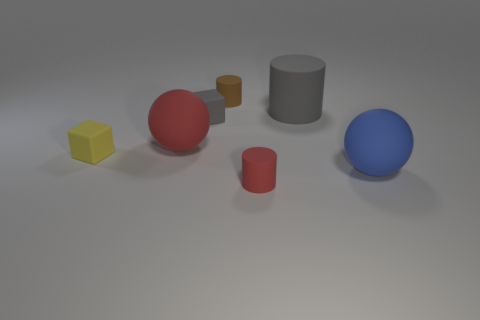Are there any gray things of the same shape as the big blue rubber object?
Make the answer very short. No. Is the number of big yellow shiny spheres less than the number of gray matte cylinders?
Your response must be concise. Yes. Do the small brown thing and the tiny red matte thing have the same shape?
Your answer should be compact. Yes. What number of objects are large blue rubber spheres or red rubber things in front of the yellow rubber cube?
Keep it short and to the point. 2. How many large gray cylinders are there?
Offer a very short reply. 1. Are there any red things of the same size as the yellow rubber block?
Provide a succinct answer. Yes. Is the number of big things that are in front of the big red thing less than the number of brown matte cubes?
Your response must be concise. No. Is the size of the yellow thing the same as the brown rubber cylinder?
Offer a very short reply. Yes. There is a gray block that is made of the same material as the tiny brown thing; what is its size?
Provide a short and direct response. Small. How many tiny objects are the same color as the big cylinder?
Make the answer very short. 1. 